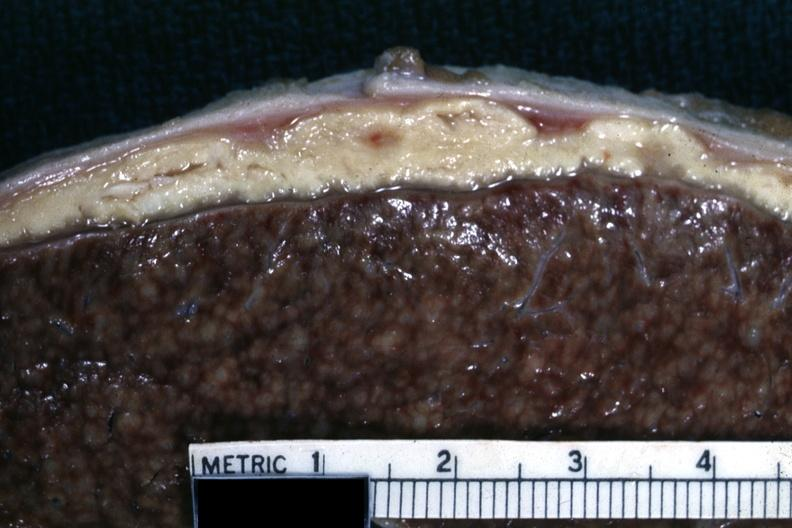does this image show close-up of liver with typical gray caseous looking material that can be seen with tuberculous peritonitis?
Answer the question using a single word or phrase. Yes 